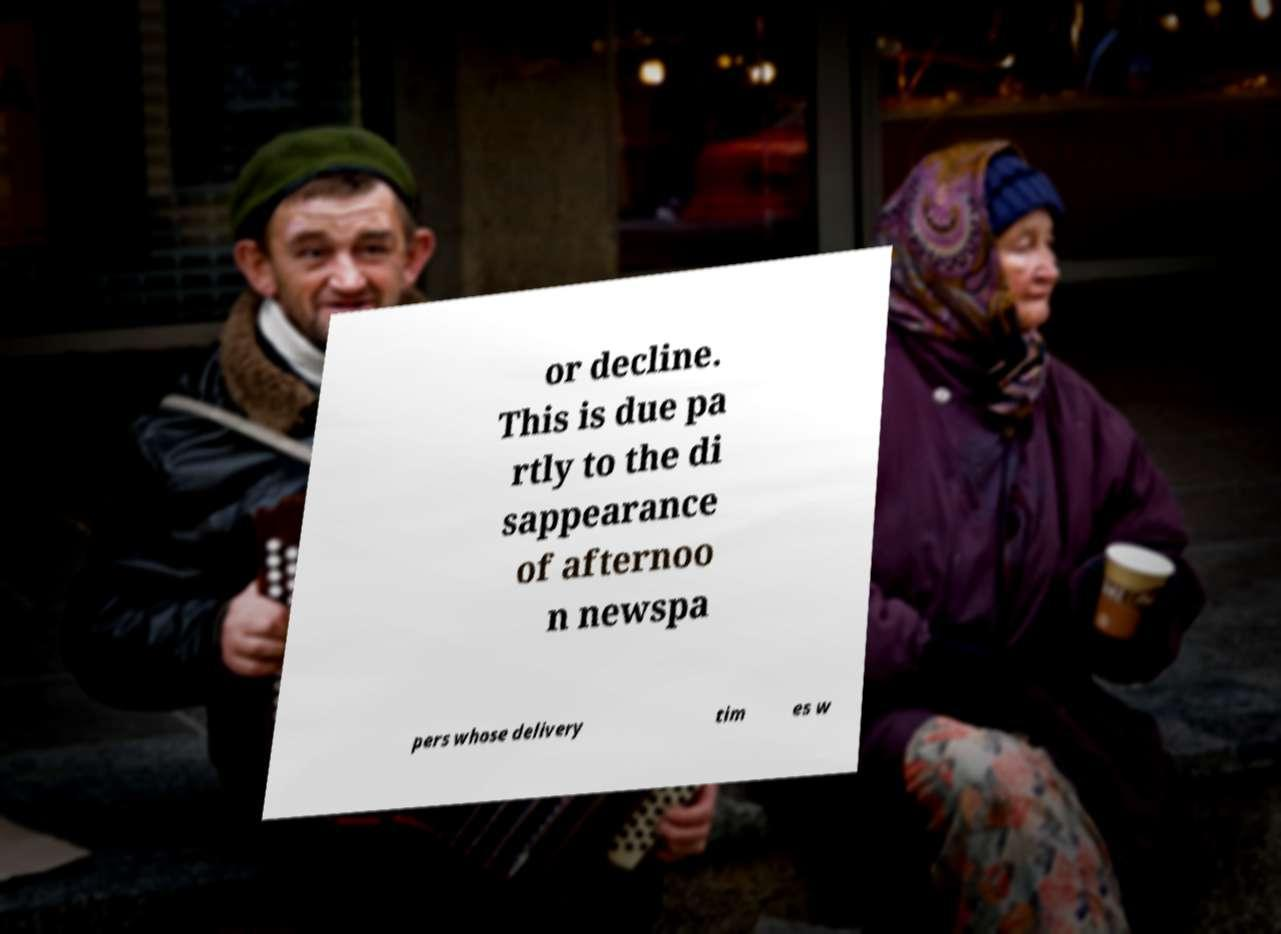Could you assist in decoding the text presented in this image and type it out clearly? or decline. This is due pa rtly to the di sappearance of afternoo n newspa pers whose delivery tim es w 